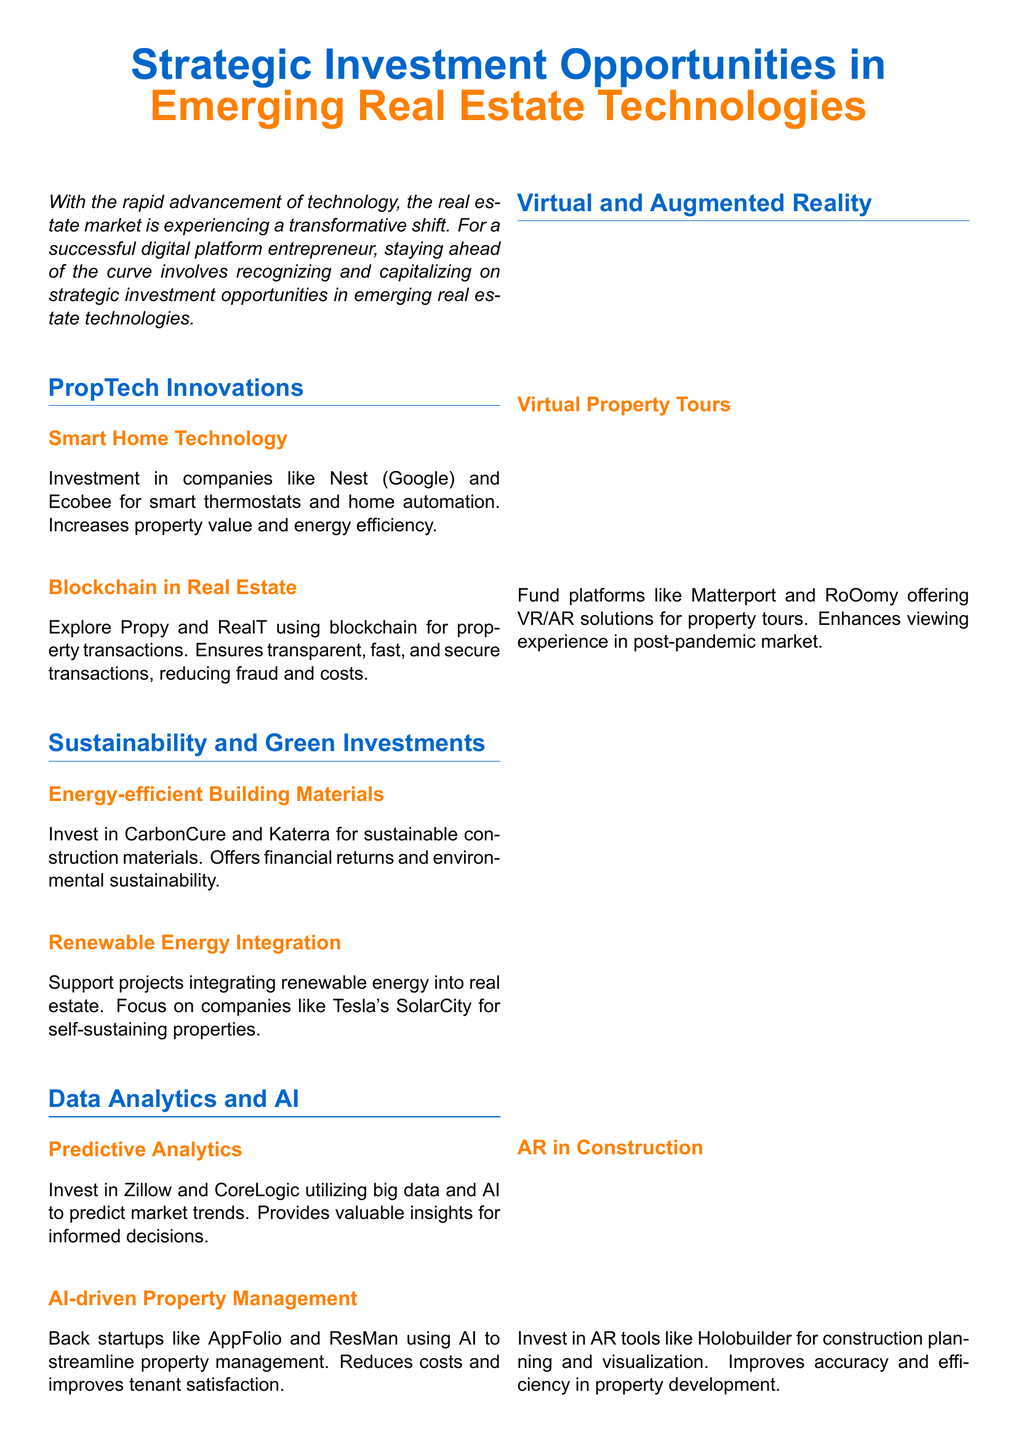What are the two main categories highlighted in the document? The document identifies "PropTech Innovations" and "Sustainability and Green Investments" as the main categories for strategic investment opportunities.
Answer: PropTech Innovations, Sustainability and Green Investments Which company is mentioned for investing in smart home technology? Nest (Google) is specifically mentioned as a key player in smart home technology within the document.
Answer: Nest (Google) What technology is used by Propy and RealT for property transactions? The document states that these companies utilize blockchain technology to ensure secure transactions.
Answer: Blockchain What type of analytics is mentioned for predicting market trends? The document refers to "Predictive Analytics" as the type of analytics being utilized for forecasting market trends.
Answer: Predictive Analytics Which company is associated with renewable energy integration? The document highlights Tesla's SolarCity as a notable example in the integration of renewable energy into real estate projects.
Answer: Tesla's SolarCity How does investing in Energy-efficient Building Materials benefit investors? The document indicates that investing in these materials offers both financial returns and environmental sustainability.
Answer: Financial returns and environmental sustainability What is the purpose of AI-driven property management? According to the document, the purpose of AI-driven property management is to streamline property management practices.
Answer: Streamline property management Which technology enhances the viewing experience for properties? The use of Virtual and Augmented Reality enhances the property viewing experience, especially in the post-pandemic market according to the document.
Answer: Virtual and Augmented Reality What should tech entrepreneurs leverage to maintain a competitive edge? The document advises tech entrepreneurs to leverage emerging technologies to maintain a competitive edge in the real estate industry.
Answer: Emerging technologies 